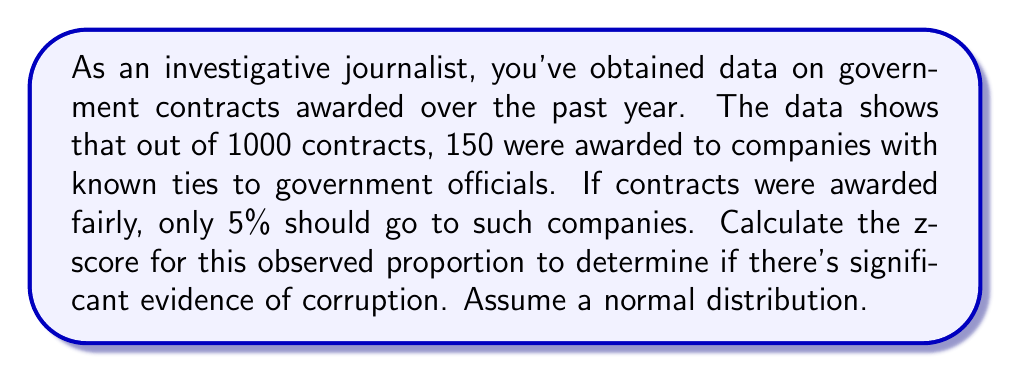Teach me how to tackle this problem. To calculate the z-score, we'll use the formula:

$$ z = \frac{\hat{p} - p}{\sqrt{\frac{p(1-p)}{n}}} $$

Where:
$\hat{p}$ = observed proportion
$p$ = expected proportion
$n$ = sample size

Step 1: Calculate the observed proportion
$\hat{p} = \frac{150}{1000} = 0.15$

Step 2: Identify the expected proportion
$p = 0.05$ (5% or 0.05 in decimal form)

Step 3: Identify the sample size
$n = 1000$

Step 4: Plug values into the z-score formula
$$ z = \frac{0.15 - 0.05}{\sqrt{\frac{0.05(1-0.05)}{1000}}} $$

Step 5: Simplify
$$ z = \frac{0.10}{\sqrt{\frac{0.0475}{1000}}} = \frac{0.10}{\sqrt{0.0000475}} = \frac{0.10}{0.006892} $$

Step 6: Calculate the final result
$$ z \approx 14.51 $$

This extremely high z-score (well above the common threshold of 1.96 for a 95% confidence level) suggests strong evidence of corruption in the contract awarding process.
Answer: 14.51 